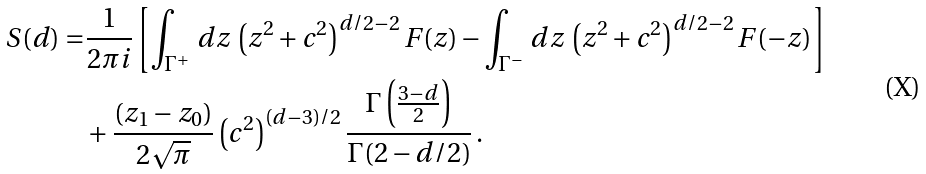<formula> <loc_0><loc_0><loc_500><loc_500>S ( d ) = & \frac { 1 } { 2 \pi i } \left [ \int _ { \Gamma ^ { + } } \, d z \, \left ( z ^ { 2 } + c ^ { 2 } \right ) ^ { d / 2 - 2 } F ( z ) - \int _ { \Gamma ^ { - } } \, d z \, \left ( z ^ { 2 } + c ^ { 2 } \right ) ^ { d / 2 - 2 } F ( - z ) \right ] \\ & + \frac { ( z _ { 1 } - z _ { 0 } ) } { 2 \sqrt { \pi } } \left ( c ^ { 2 } \right ) ^ { ( d - 3 ) / 2 } \frac { \Gamma \left ( \frac { 3 - d } { 2 } \right ) } { \Gamma ( 2 - d / 2 ) } \, .</formula> 